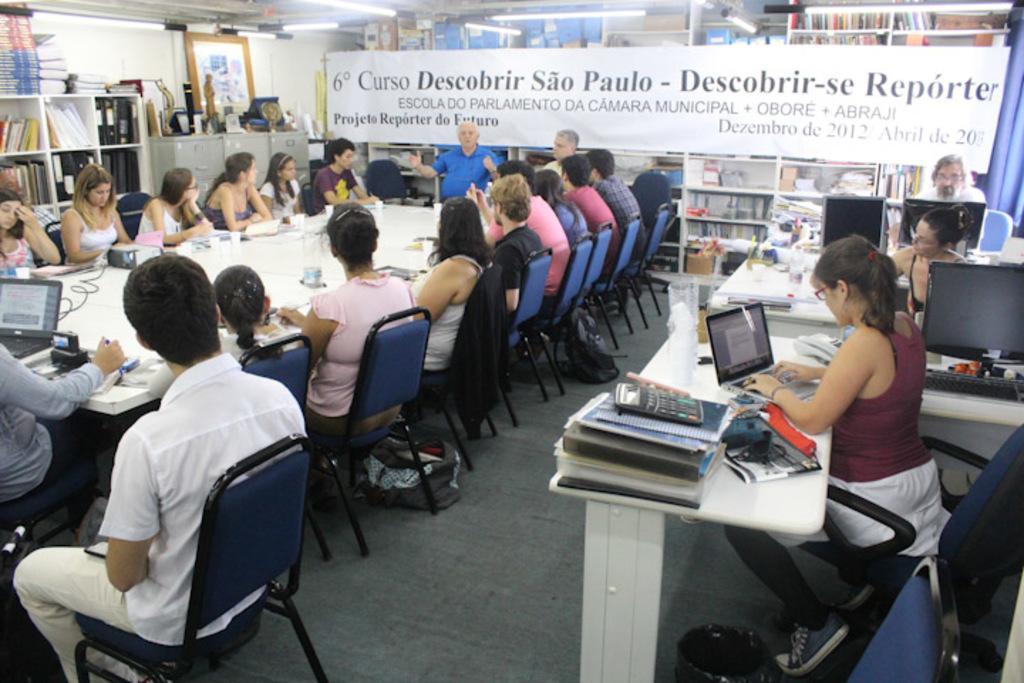Describe this image in one or two sentences. In this image there are group of people who are sitting on chairs, and also there is a table. On the table there is a laptop, cups and some other objects, and on the right side of the image there are three persons who are sitting on chairs and also there are some tables. On the tables there are some computers, books, pens, glasses and some other objects. And in the background there are some book racks, in the book racks there are some books and some boxes and some other objects. And there is one board, in the center on the board there is text and at the top of the right corner there is a curtain and on the left side of the image there are some shelves. In that shelves there are some books, photo frame, statues and some objects. At the top there is ceiling and some lights and at the bottom there is floor, on the floor there are some bags. 